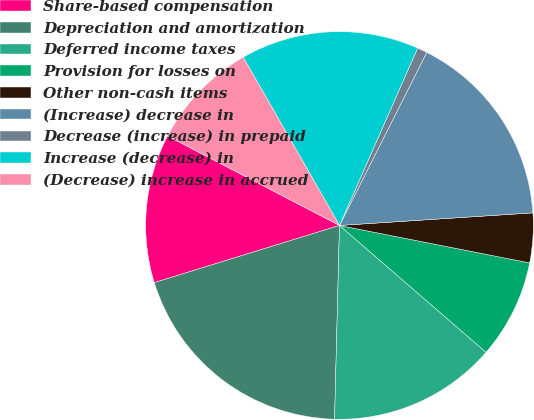Convert chart to OTSL. <chart><loc_0><loc_0><loc_500><loc_500><pie_chart><fcel>Share-based compensation<fcel>Depreciation and amortization<fcel>Deferred income taxes<fcel>Provision for losses on<fcel>Other non-cash items<fcel>(Increase) decrease in<fcel>Decrease (increase) in prepaid<fcel>Increase (decrease) in<fcel>(Decrease) increase in accrued<nl><fcel>12.4%<fcel>19.83%<fcel>14.05%<fcel>8.26%<fcel>4.13%<fcel>16.53%<fcel>0.83%<fcel>14.88%<fcel>9.09%<nl></chart> 